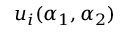Convert formula to latex. <formula><loc_0><loc_0><loc_500><loc_500>u _ { i } ( \alpha _ { 1 } , \alpha _ { 2 } )</formula> 